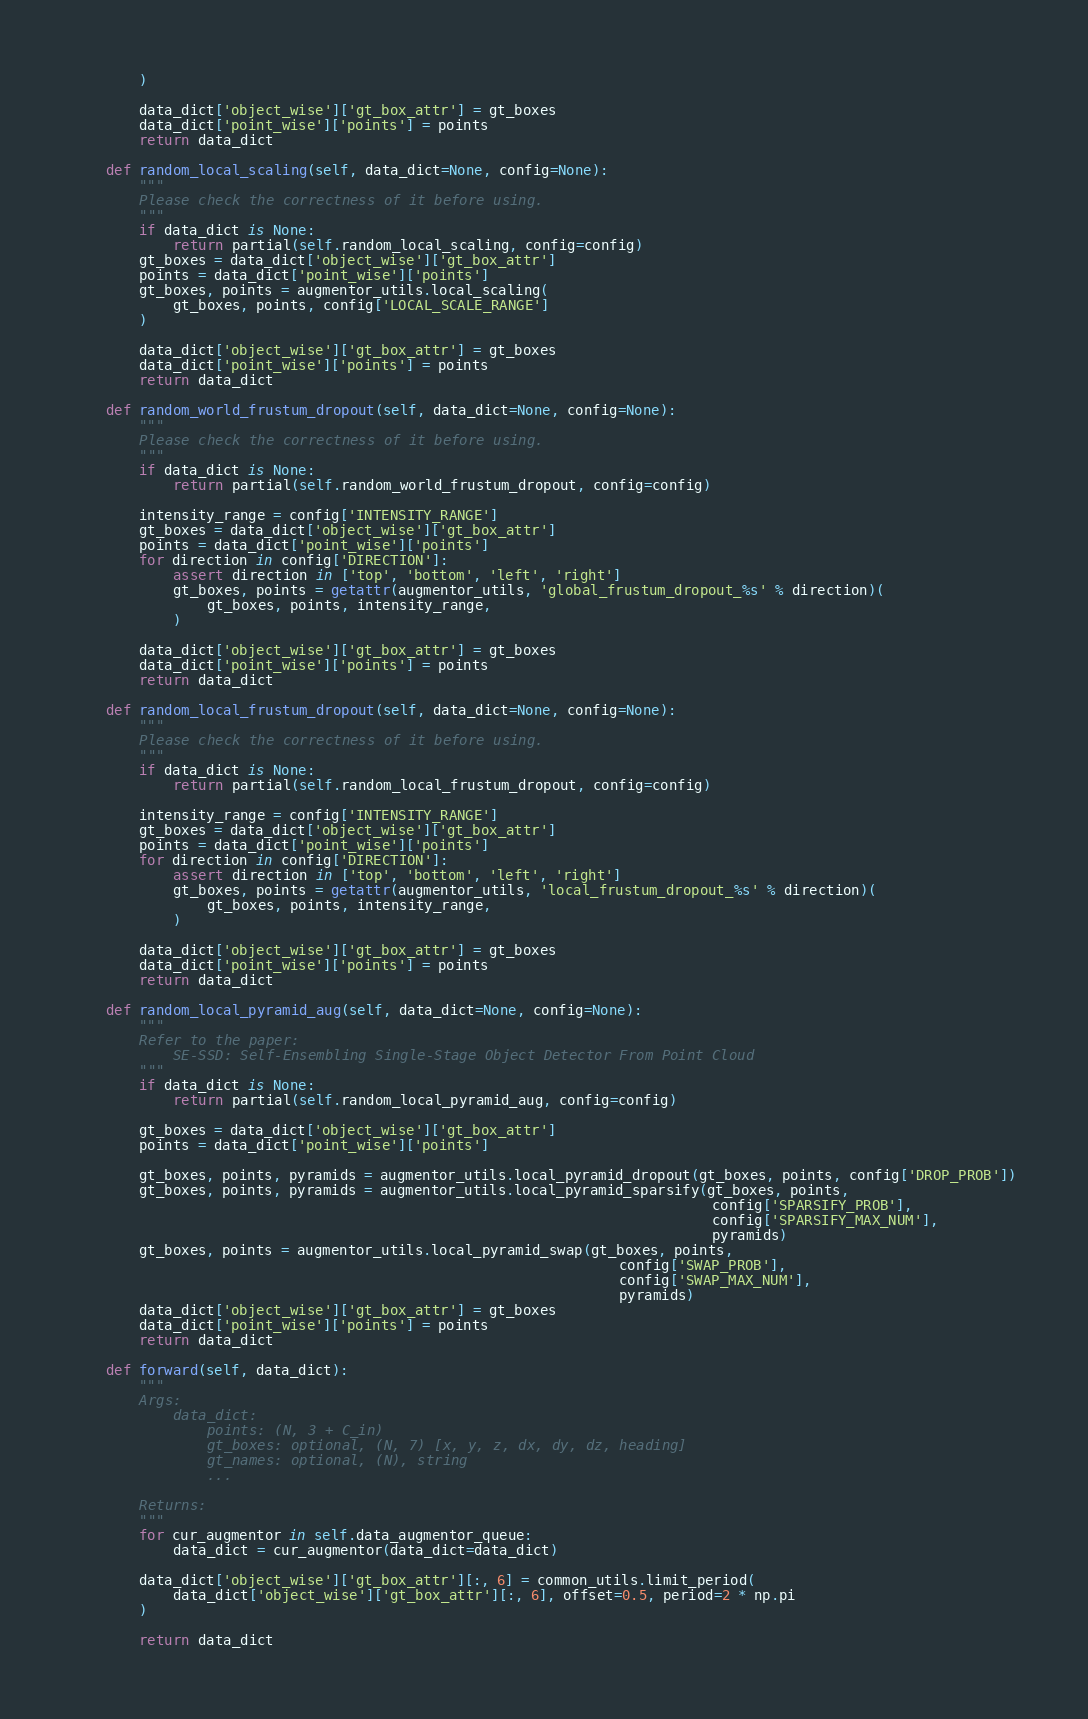Convert code to text. <code><loc_0><loc_0><loc_500><loc_500><_Python_>        )
        
        data_dict['object_wise']['gt_box_attr'] = gt_boxes
        data_dict['point_wise']['points'] = points
        return data_dict
    
    def random_local_scaling(self, data_dict=None, config=None):
        """
        Please check the correctness of it before using.
        """
        if data_dict is None:
            return partial(self.random_local_scaling, config=config)
        gt_boxes = data_dict['object_wise']['gt_box_attr']
        points = data_dict['point_wise']['points']
        gt_boxes, points = augmentor_utils.local_scaling(
            gt_boxes, points, config['LOCAL_SCALE_RANGE']
        )
        
        data_dict['object_wise']['gt_box_attr'] = gt_boxes
        data_dict['point_wise']['points'] = points
        return data_dict
    
    def random_world_frustum_dropout(self, data_dict=None, config=None):
        """
        Please check the correctness of it before using.
        """
        if data_dict is None:
            return partial(self.random_world_frustum_dropout, config=config)
        
        intensity_range = config['INTENSITY_RANGE']
        gt_boxes = data_dict['object_wise']['gt_box_attr']
        points = data_dict['point_wise']['points']
        for direction in config['DIRECTION']:
            assert direction in ['top', 'bottom', 'left', 'right']
            gt_boxes, points = getattr(augmentor_utils, 'global_frustum_dropout_%s' % direction)(
                gt_boxes, points, intensity_range,
            )
        
        data_dict['object_wise']['gt_box_attr'] = gt_boxes
        data_dict['point_wise']['points'] = points
        return data_dict
    
    def random_local_frustum_dropout(self, data_dict=None, config=None):
        """
        Please check the correctness of it before using.
        """
        if data_dict is None:
            return partial(self.random_local_frustum_dropout, config=config)
        
        intensity_range = config['INTENSITY_RANGE']
        gt_boxes = data_dict['object_wise']['gt_box_attr']
        points = data_dict['point_wise']['points']
        for direction in config['DIRECTION']:
            assert direction in ['top', 'bottom', 'left', 'right']
            gt_boxes, points = getattr(augmentor_utils, 'local_frustum_dropout_%s' % direction)(
                gt_boxes, points, intensity_range,
            )
        
        data_dict['object_wise']['gt_box_attr'] = gt_boxes
        data_dict['point_wise']['points'] = points
        return data_dict
    
    def random_local_pyramid_aug(self, data_dict=None, config=None):
        """
        Refer to the paper: 
            SE-SSD: Self-Ensembling Single-Stage Object Detector From Point Cloud
        """
        if data_dict is None:
            return partial(self.random_local_pyramid_aug, config=config)
        
        gt_boxes = data_dict['object_wise']['gt_box_attr']
        points = data_dict['point_wise']['points']
        
        gt_boxes, points, pyramids = augmentor_utils.local_pyramid_dropout(gt_boxes, points, config['DROP_PROB'])
        gt_boxes, points, pyramids = augmentor_utils.local_pyramid_sparsify(gt_boxes, points,
                                                                            config['SPARSIFY_PROB'],
                                                                            config['SPARSIFY_MAX_NUM'],
                                                                            pyramids)
        gt_boxes, points = augmentor_utils.local_pyramid_swap(gt_boxes, points,
                                                                 config['SWAP_PROB'],
                                                                 config['SWAP_MAX_NUM'],
                                                                 pyramids)
        data_dict['object_wise']['gt_box_attr'] = gt_boxes
        data_dict['point_wise']['points'] = points
        return data_dict

    def forward(self, data_dict):
        """
        Args:
            data_dict:
                points: (N, 3 + C_in)
                gt_boxes: optional, (N, 7) [x, y, z, dx, dy, dz, heading]
                gt_names: optional, (N), string
                ...

        Returns:
        """
        for cur_augmentor in self.data_augmentor_queue:
            data_dict = cur_augmentor(data_dict=data_dict)
        
        data_dict['object_wise']['gt_box_attr'][:, 6] = common_utils.limit_period(
            data_dict['object_wise']['gt_box_attr'][:, 6], offset=0.5, period=2 * np.pi
        )

        return data_dict
</code> 